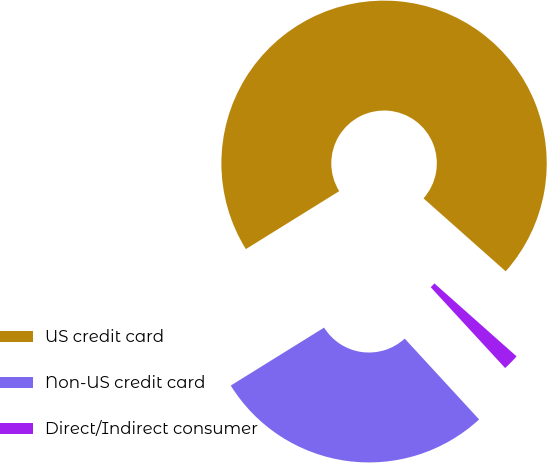<chart> <loc_0><loc_0><loc_500><loc_500><pie_chart><fcel>US credit card<fcel>Non-US credit card<fcel>Direct/Indirect consumer<nl><fcel>70.4%<fcel>28.0%<fcel>1.6%<nl></chart> 